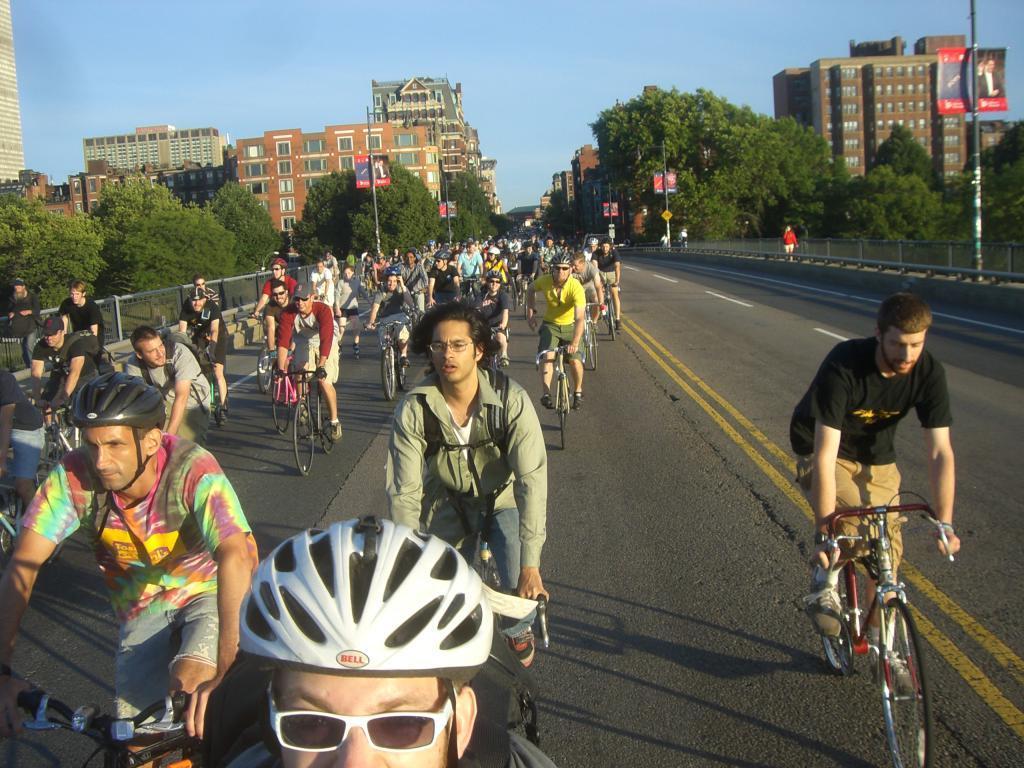How would you summarize this image in a sentence or two? In this picture I can see some people are riding bicycles on the road, behind I can see some buildings and trees. 